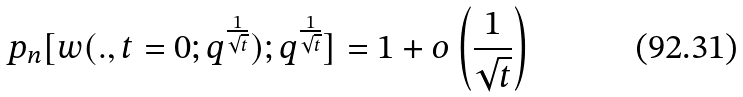Convert formula to latex. <formula><loc_0><loc_0><loc_500><loc_500>p _ { n } [ w ( . , t = 0 ; q ^ { \frac { 1 } { \sqrt { t } } } ) ; q ^ { \frac { 1 } { \sqrt { t } } } ] = 1 + o \left ( \frac { 1 } { \sqrt { t } } \right )</formula> 